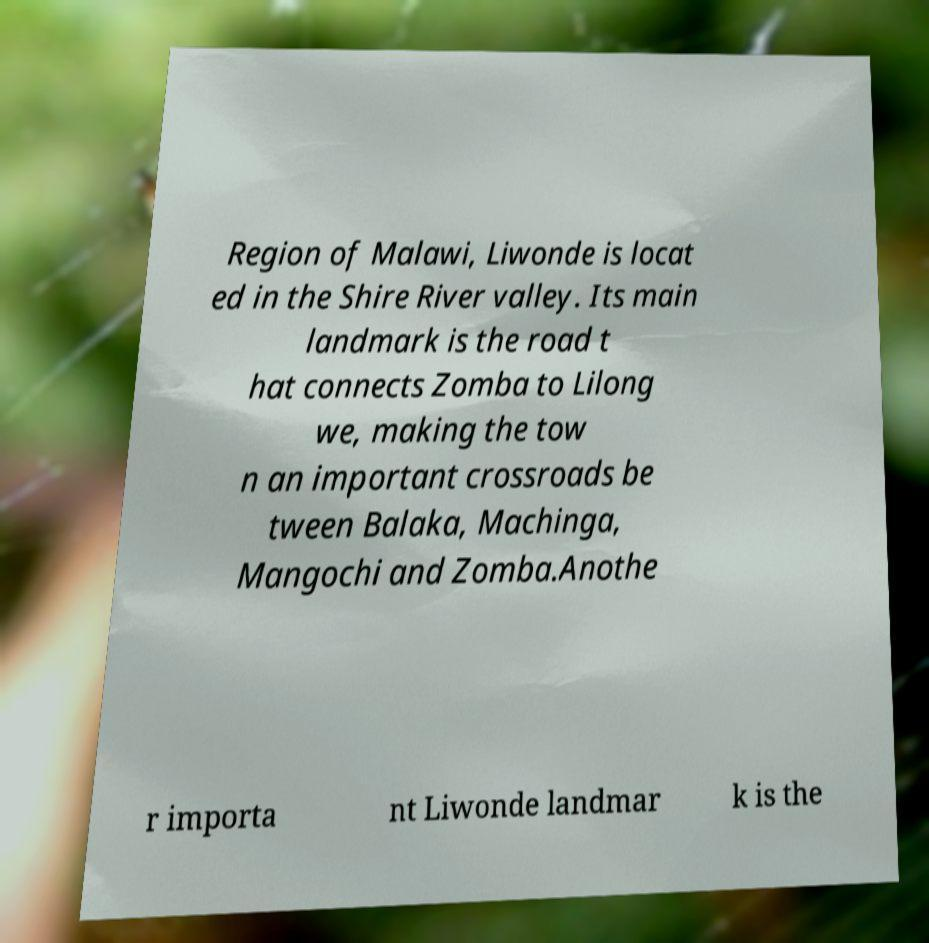There's text embedded in this image that I need extracted. Can you transcribe it verbatim? Region of Malawi, Liwonde is locat ed in the Shire River valley. Its main landmark is the road t hat connects Zomba to Lilong we, making the tow n an important crossroads be tween Balaka, Machinga, Mangochi and Zomba.Anothe r importa nt Liwonde landmar k is the 